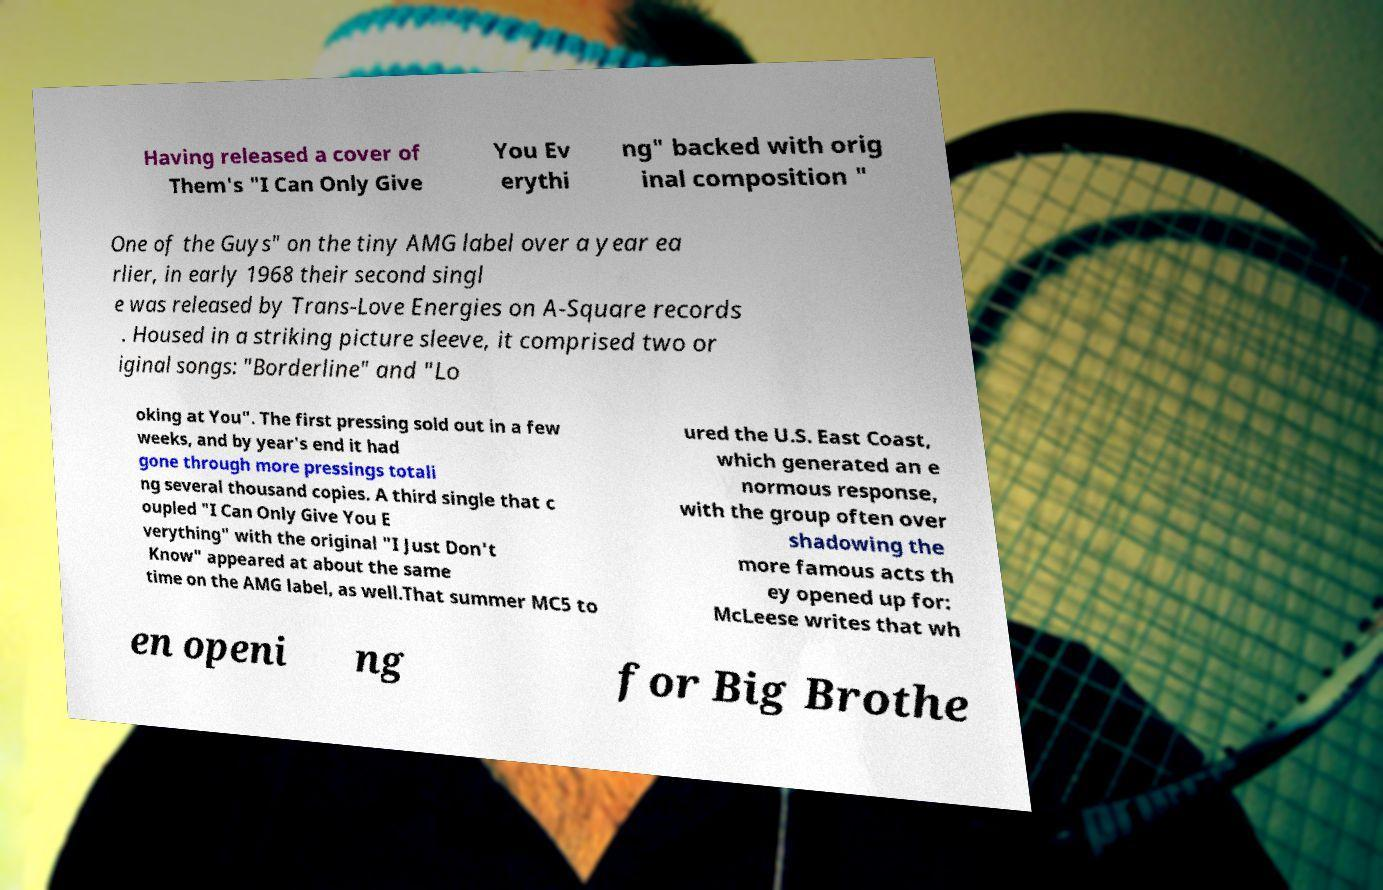There's text embedded in this image that I need extracted. Can you transcribe it verbatim? Having released a cover of Them's "I Can Only Give You Ev erythi ng" backed with orig inal composition " One of the Guys" on the tiny AMG label over a year ea rlier, in early 1968 their second singl e was released by Trans-Love Energies on A-Square records . Housed in a striking picture sleeve, it comprised two or iginal songs: "Borderline" and "Lo oking at You". The first pressing sold out in a few weeks, and by year's end it had gone through more pressings totali ng several thousand copies. A third single that c oupled "I Can Only Give You E verything" with the original "I Just Don't Know" appeared at about the same time on the AMG label, as well.That summer MC5 to ured the U.S. East Coast, which generated an e normous response, with the group often over shadowing the more famous acts th ey opened up for: McLeese writes that wh en openi ng for Big Brothe 